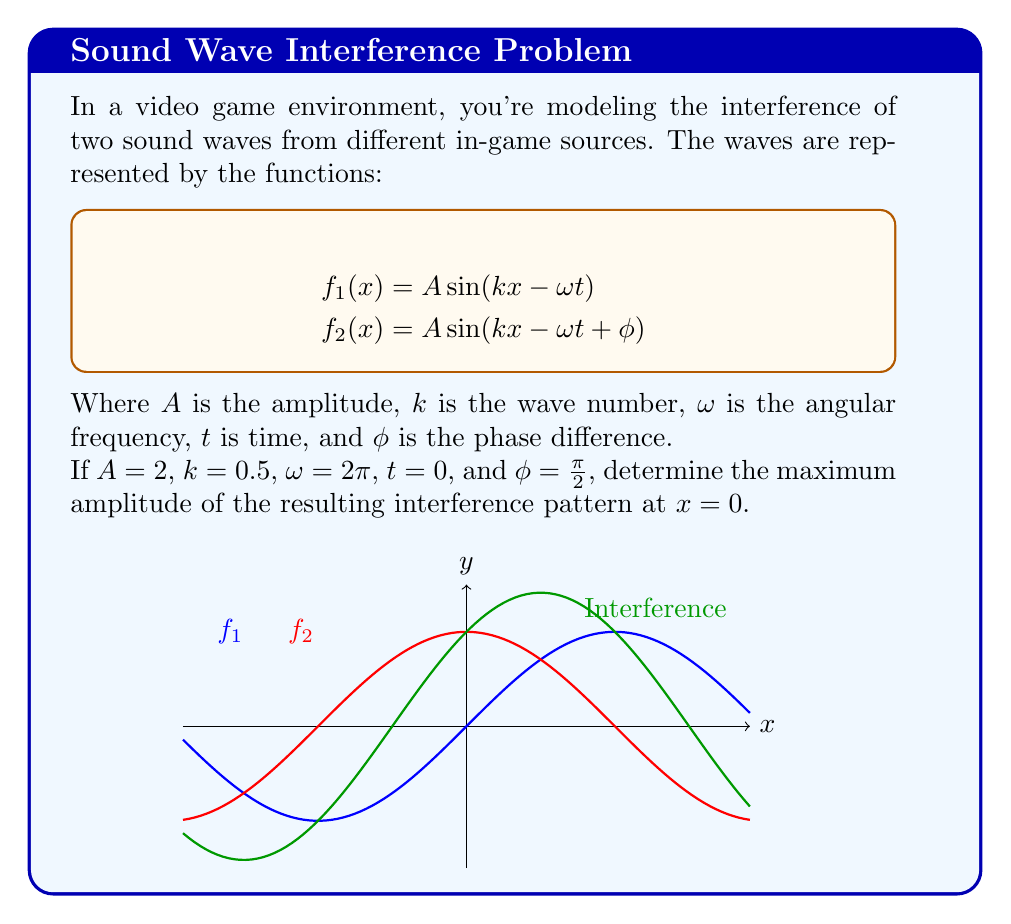Give your solution to this math problem. Let's approach this step-by-step:

1) The interference pattern is given by the superposition of the two waves:
   $$f(x) = f_1(x) + f_2(x)$$

2) Substituting the given values into the wave equations at $x = 0$ and $t = 0$:
   $$f_1(0) = 2 \sin(0.5 \cdot 0 - 2\pi \cdot 0) = 2 \sin(0) = 0$$
   $$f_2(0) = 2 \sin(0.5 \cdot 0 - 2\pi \cdot 0 + \frac{\pi}{2}) = 2 \sin(\frac{\pi}{2}) = 2$$

3) The resulting amplitude at $x = 0$ is:
   $$f(0) = f_1(0) + f_2(0) = 0 + 2 = 2$$

4) However, this is not necessarily the maximum amplitude. To find the maximum, we need to consider the general case:
   $$f(x) = A[\sin(kx - \omega t) + \sin(kx - \omega t + \phi)]$$

5) Using the trigonometric identity for the sum of sines:
   $$f(x) = 2A \sin(kx - \omega t + \frac{\phi}{2}) \cos(\frac{\phi}{2})$$

6) The amplitude of this combined wave is:
   $$2A \cos(\frac{\phi}{2})$$

7) Substituting our values:
   $$2 \cdot 2 \cos(\frac{\pi}{4}) = 4 \cos(\frac{\pi}{4}) = 4 \cdot \frac{\sqrt{2}}{2} = 2\sqrt{2}$$

This is the maximum amplitude of the interference pattern.
Answer: $2\sqrt{2}$ 